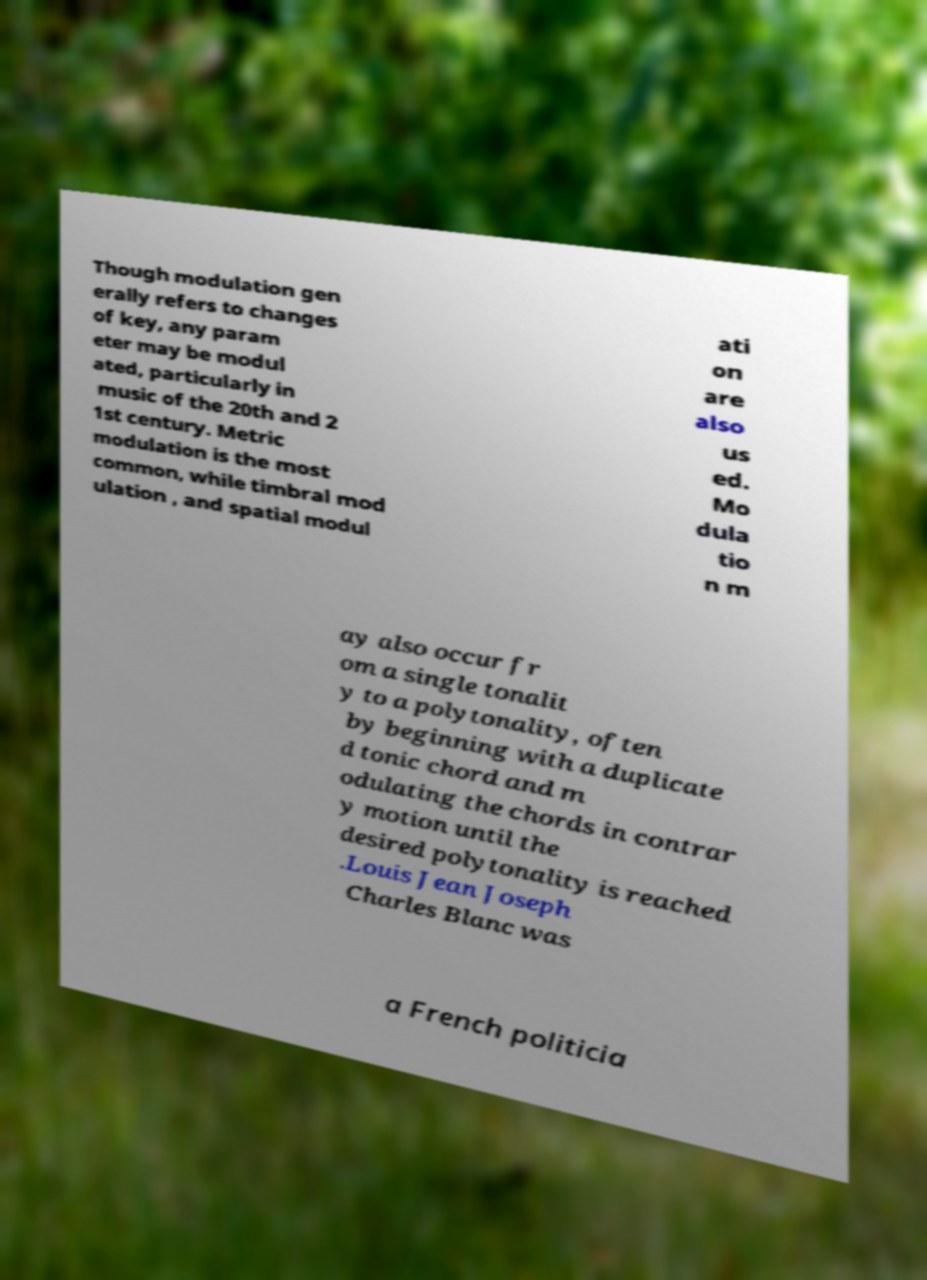There's text embedded in this image that I need extracted. Can you transcribe it verbatim? Though modulation gen erally refers to changes of key, any param eter may be modul ated, particularly in music of the 20th and 2 1st century. Metric modulation is the most common, while timbral mod ulation , and spatial modul ati on are also us ed. Mo dula tio n m ay also occur fr om a single tonalit y to a polytonality, often by beginning with a duplicate d tonic chord and m odulating the chords in contrar y motion until the desired polytonality is reached .Louis Jean Joseph Charles Blanc was a French politicia 